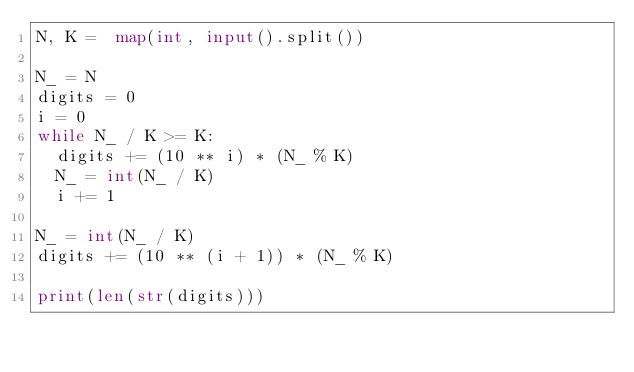<code> <loc_0><loc_0><loc_500><loc_500><_Python_>N, K =  map(int, input().split())

N_ = N
digits = 0
i = 0
while N_ / K >= K:
  digits += (10 ** i) * (N_ % K)
  N_ = int(N_ / K)
  i += 1

N_ = int(N_ / K)
digits += (10 ** (i + 1)) * (N_ % K)

print(len(str(digits)))</code> 